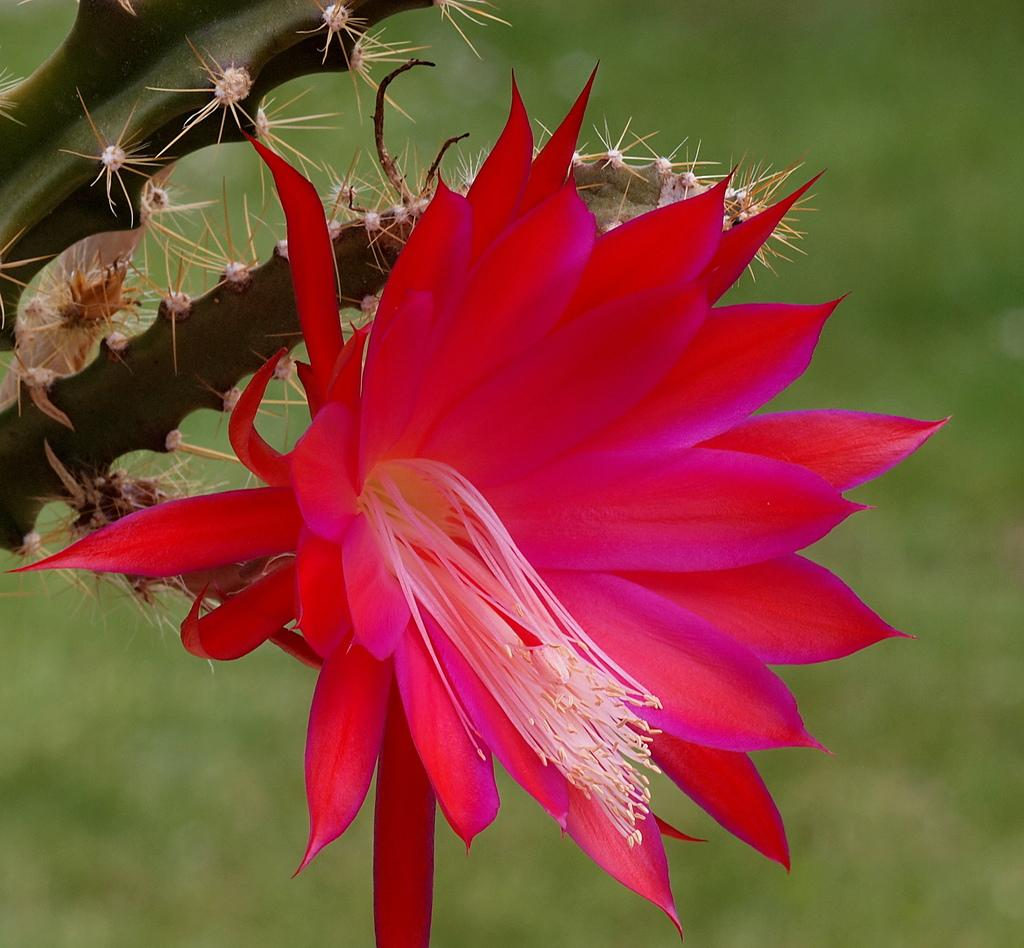What type of flower is present in the image? There is a red color flower in the image. What plant is the flower attached to? The flower is attached to a cactus plant. What color is the background of the image? The background of the image is green in color. How many houses can be seen in the image? There are no houses present in the image; it features a red color flower attached to a cactus plant with a green background. 